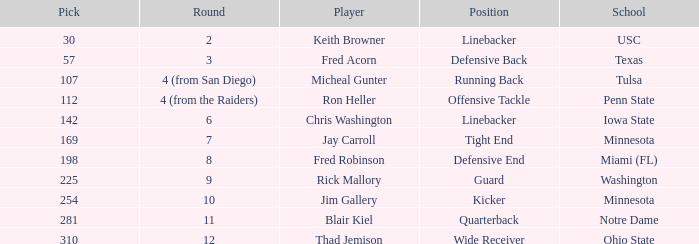The 112th pick is in which round? 4 (from the Raiders). 